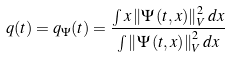<formula> <loc_0><loc_0><loc_500><loc_500>q ( t ) = q _ { \Psi } ( t ) = \frac { \int x \left \| \Psi \left ( t , x \right ) \right \| _ { V } ^ { 2 } d x } { \int \left \| \Psi \left ( t , x \right ) \right \| _ { V } ^ { 2 } d x }</formula> 